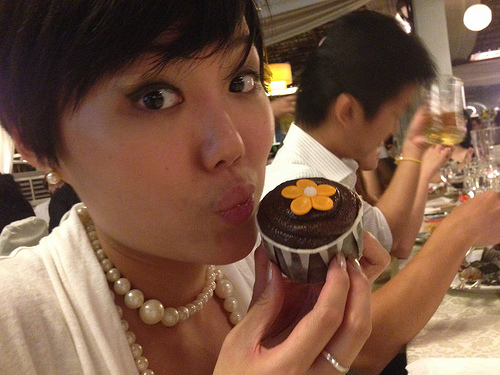Who holds the cake? The cake is being held by a person visible in the image. 